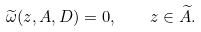Convert formula to latex. <formula><loc_0><loc_0><loc_500><loc_500>\widetilde { \omega } ( z , A , D ) = 0 , \quad z \in \widetilde { A } .</formula> 